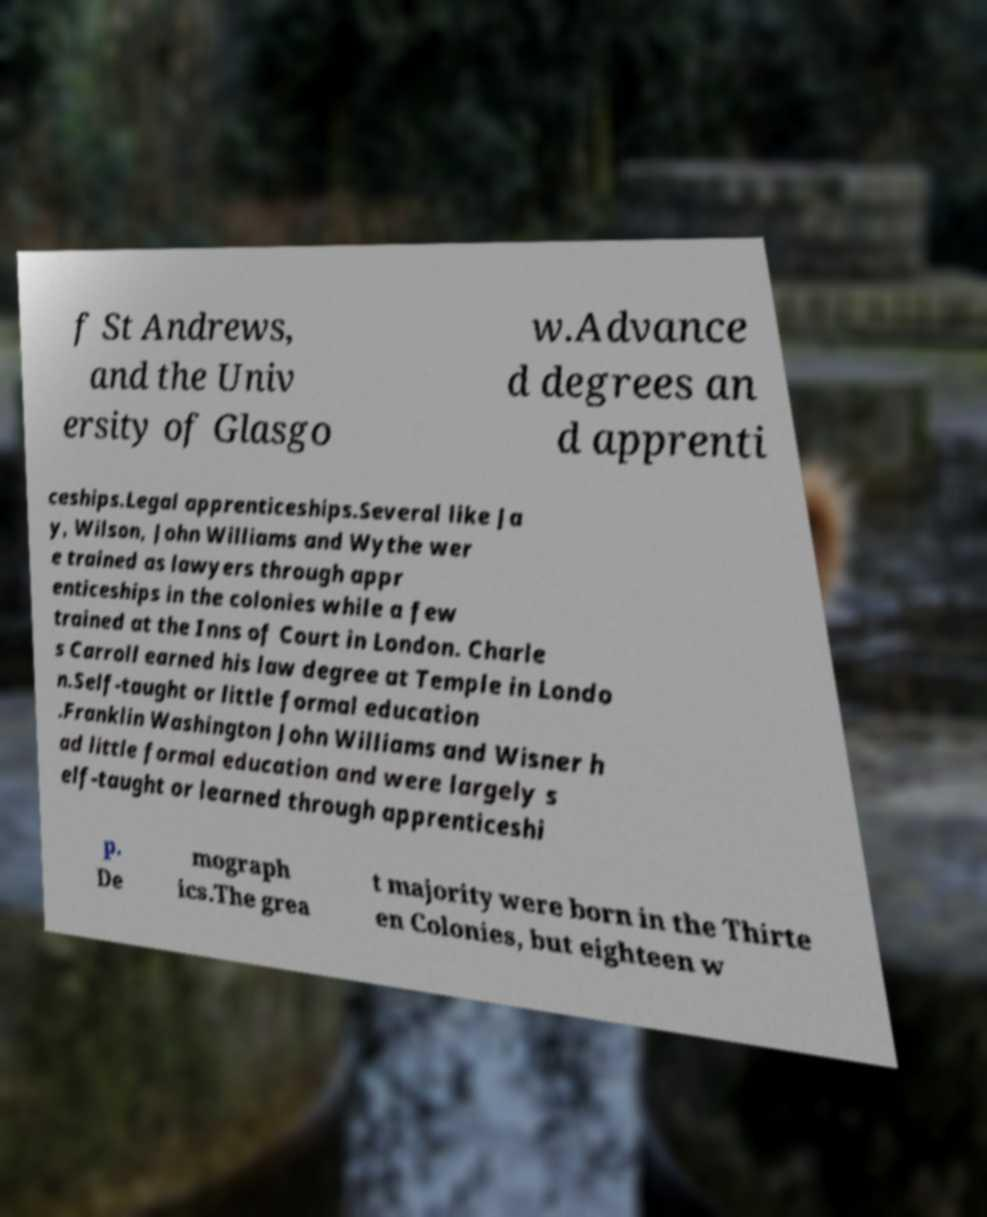Can you read and provide the text displayed in the image?This photo seems to have some interesting text. Can you extract and type it out for me? f St Andrews, and the Univ ersity of Glasgo w.Advance d degrees an d apprenti ceships.Legal apprenticeships.Several like Ja y, Wilson, John Williams and Wythe wer e trained as lawyers through appr enticeships in the colonies while a few trained at the Inns of Court in London. Charle s Carroll earned his law degree at Temple in Londo n.Self-taught or little formal education .Franklin Washington John Williams and Wisner h ad little formal education and were largely s elf-taught or learned through apprenticeshi p. De mograph ics.The grea t majority were born in the Thirte en Colonies, but eighteen w 